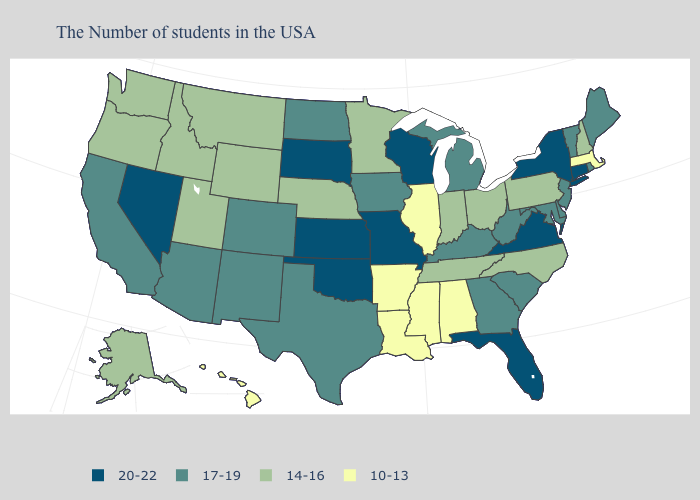How many symbols are there in the legend?
Write a very short answer. 4. Is the legend a continuous bar?
Be succinct. No. Which states hav the highest value in the West?
Write a very short answer. Nevada. Does North Dakota have the highest value in the MidWest?
Short answer required. No. What is the value of Virginia?
Give a very brief answer. 20-22. Does the map have missing data?
Keep it brief. No. What is the value of Alabama?
Quick response, please. 10-13. What is the highest value in states that border Kansas?
Short answer required. 20-22. Name the states that have a value in the range 14-16?
Short answer required. New Hampshire, Pennsylvania, North Carolina, Ohio, Indiana, Tennessee, Minnesota, Nebraska, Wyoming, Utah, Montana, Idaho, Washington, Oregon, Alaska. Which states have the highest value in the USA?
Give a very brief answer. Connecticut, New York, Virginia, Florida, Wisconsin, Missouri, Kansas, Oklahoma, South Dakota, Nevada. Does Montana have a lower value than Minnesota?
Quick response, please. No. What is the value of South Carolina?
Short answer required. 17-19. Name the states that have a value in the range 10-13?
Short answer required. Massachusetts, Alabama, Illinois, Mississippi, Louisiana, Arkansas, Hawaii. What is the lowest value in the USA?
Answer briefly. 10-13. Name the states that have a value in the range 14-16?
Give a very brief answer. New Hampshire, Pennsylvania, North Carolina, Ohio, Indiana, Tennessee, Minnesota, Nebraska, Wyoming, Utah, Montana, Idaho, Washington, Oregon, Alaska. 